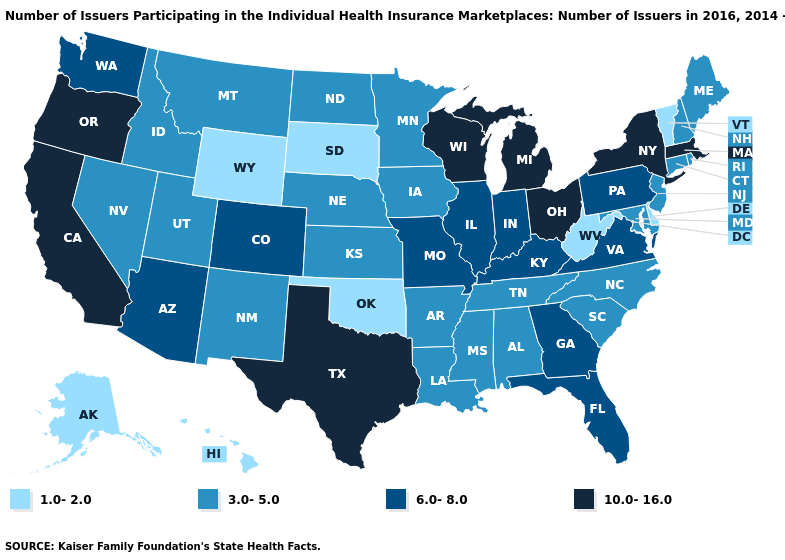Does the first symbol in the legend represent the smallest category?
Write a very short answer. Yes. What is the value of Colorado?
Short answer required. 6.0-8.0. What is the highest value in states that border Washington?
Quick response, please. 10.0-16.0. What is the highest value in the South ?
Give a very brief answer. 10.0-16.0. What is the highest value in states that border Arizona?
Answer briefly. 10.0-16.0. Does Hawaii have the lowest value in the West?
Answer briefly. Yes. What is the value of Arizona?
Keep it brief. 6.0-8.0. What is the lowest value in the USA?
Write a very short answer. 1.0-2.0. Is the legend a continuous bar?
Write a very short answer. No. Is the legend a continuous bar?
Quick response, please. No. Does Iowa have the same value as Pennsylvania?
Give a very brief answer. No. Does the map have missing data?
Answer briefly. No. What is the value of Kansas?
Quick response, please. 3.0-5.0. What is the lowest value in states that border Maine?
Write a very short answer. 3.0-5.0. 